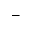<formula> <loc_0><loc_0><loc_500><loc_500>{ } -</formula> 